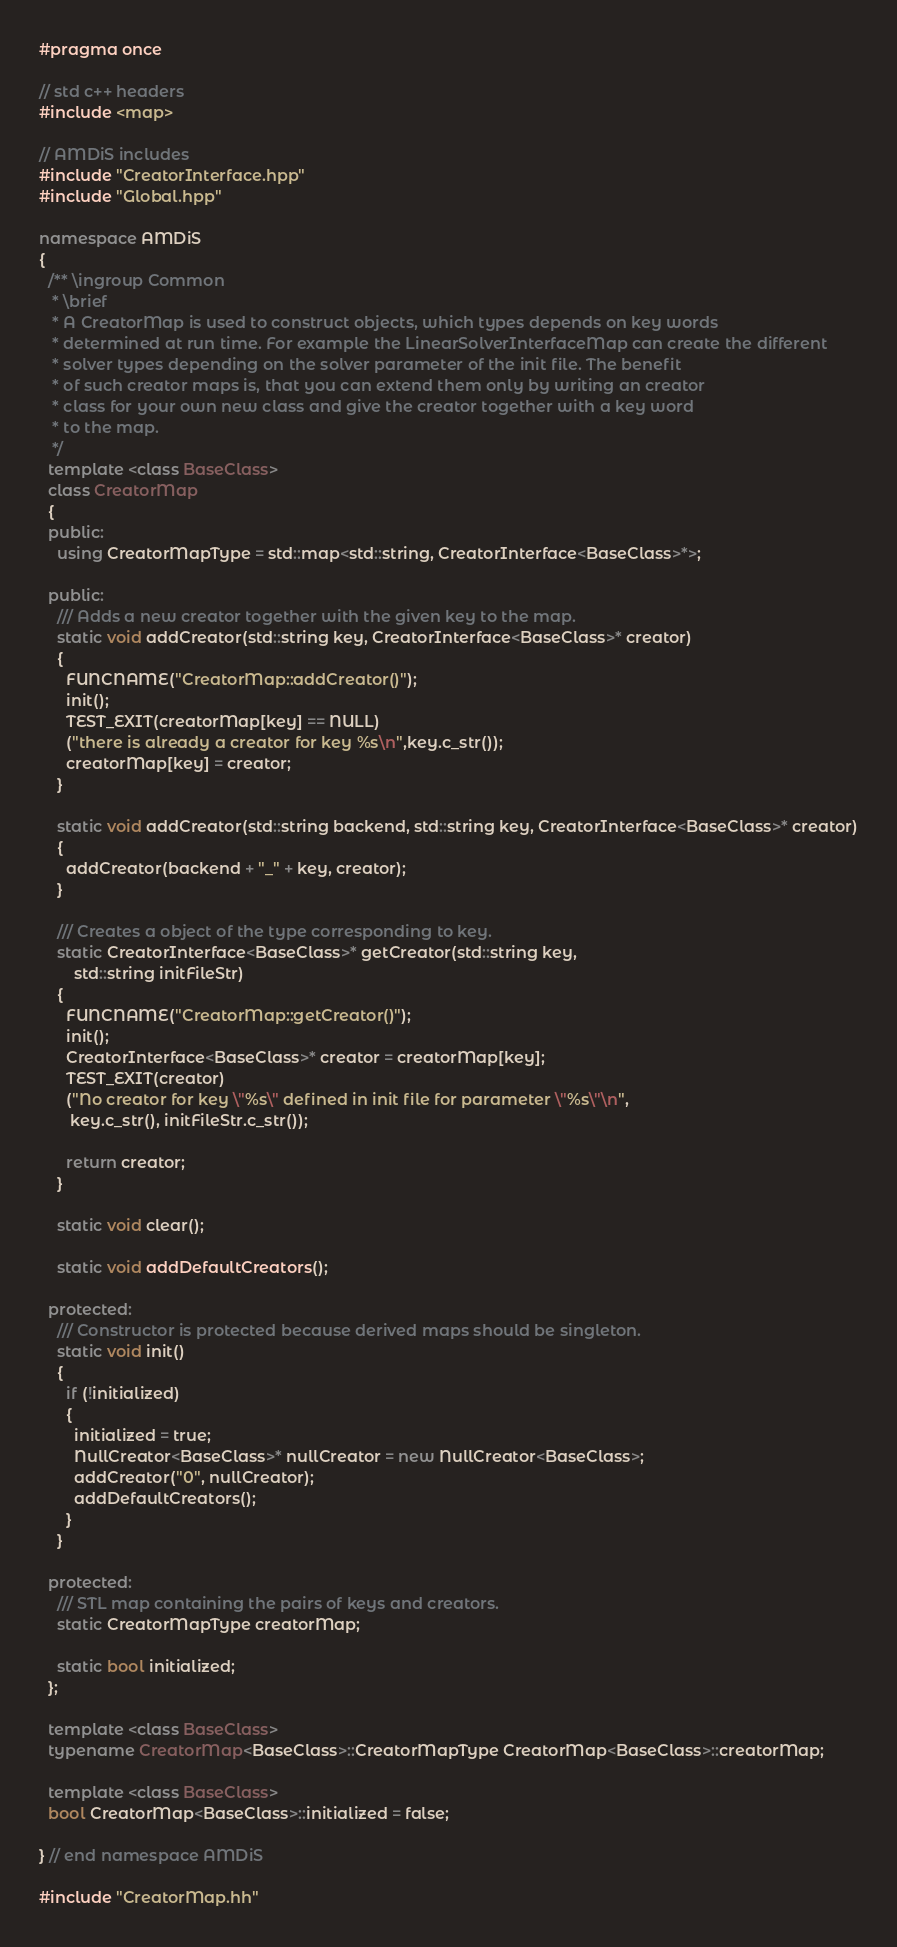<code> <loc_0><loc_0><loc_500><loc_500><_C++_>#pragma once

// std c++ headers
#include <map>

// AMDiS includes
#include "CreatorInterface.hpp"
#include "Global.hpp"

namespace AMDiS
{
  /** \ingroup Common
   * \brief
   * A CreatorMap is used to construct objects, which types depends on key words
   * determined at run time. For example the LinearSolverInterfaceMap can create the different
   * solver types depending on the solver parameter of the init file. The benefit
   * of such creator maps is, that you can extend them only by writing an creator
   * class for your own new class and give the creator together with a key word
   * to the map.
   */
  template <class BaseClass>
  class CreatorMap
  {
  public:
    using CreatorMapType = std::map<std::string, CreatorInterface<BaseClass>*>;

  public:
    /// Adds a new creator together with the given key to the map.
    static void addCreator(std::string key, CreatorInterface<BaseClass>* creator)
    {
      FUNCNAME("CreatorMap::addCreator()");
      init();
      TEST_EXIT(creatorMap[key] == NULL)
      ("there is already a creator for key %s\n",key.c_str());
      creatorMap[key] = creator;
    }

    static void addCreator(std::string backend, std::string key, CreatorInterface<BaseClass>* creator)
    {
      addCreator(backend + "_" + key, creator);
    }

    /// Creates a object of the type corresponding to key.
    static CreatorInterface<BaseClass>* getCreator(std::string key,
        std::string initFileStr)
    {
      FUNCNAME("CreatorMap::getCreator()");
      init();
      CreatorInterface<BaseClass>* creator = creatorMap[key];
      TEST_EXIT(creator)
      ("No creator for key \"%s\" defined in init file for parameter \"%s\"\n",
       key.c_str(), initFileStr.c_str());

      return creator;
    }

    static void clear();

    static void addDefaultCreators();

  protected:
    /// Constructor is protected because derived maps should be singleton.
    static void init()
    {
      if (!initialized)
      {
        initialized = true;
        NullCreator<BaseClass>* nullCreator = new NullCreator<BaseClass>;
        addCreator("0", nullCreator);
        addDefaultCreators();
      }
    }

  protected:
    /// STL map containing the pairs of keys and creators.
    static CreatorMapType creatorMap;

    static bool initialized;
  };

  template <class BaseClass>
  typename CreatorMap<BaseClass>::CreatorMapType CreatorMap<BaseClass>::creatorMap;

  template <class BaseClass>
  bool CreatorMap<BaseClass>::initialized = false;

} // end namespace AMDiS

#include "CreatorMap.hh"
</code> 